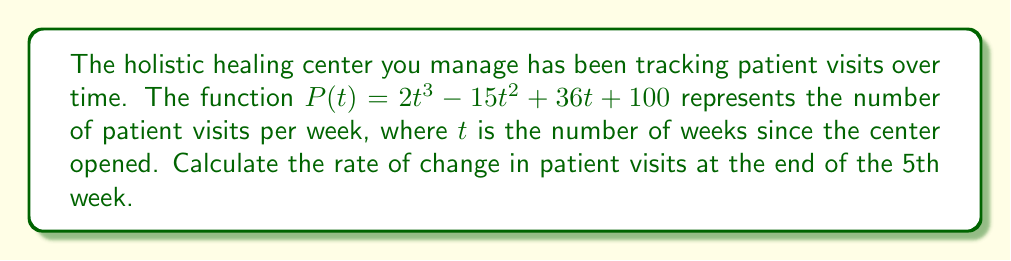Solve this math problem. To find the rate of change in patient visits at the end of the 5th week, we need to calculate the derivative of $P(t)$ and evaluate it at $t=5$. Here's how we do it:

1. The given function is $P(t) = 2t^3 - 15t^2 + 36t + 100$

2. To find the derivative, we apply the power rule and constant rule:
   $$P'(t) = 6t^2 - 30t + 36$$

3. Now we evaluate $P'(t)$ at $t=5$:
   $$P'(5) = 6(5)^2 - 30(5) + 36$$

4. Simplify:
   $$P'(5) = 6(25) - 150 + 36$$
   $$P'(5) = 150 - 150 + 36$$
   $$P'(5) = 36$$

The rate of change at $t=5$ is 36 patients per week.
Answer: 36 patients/week 